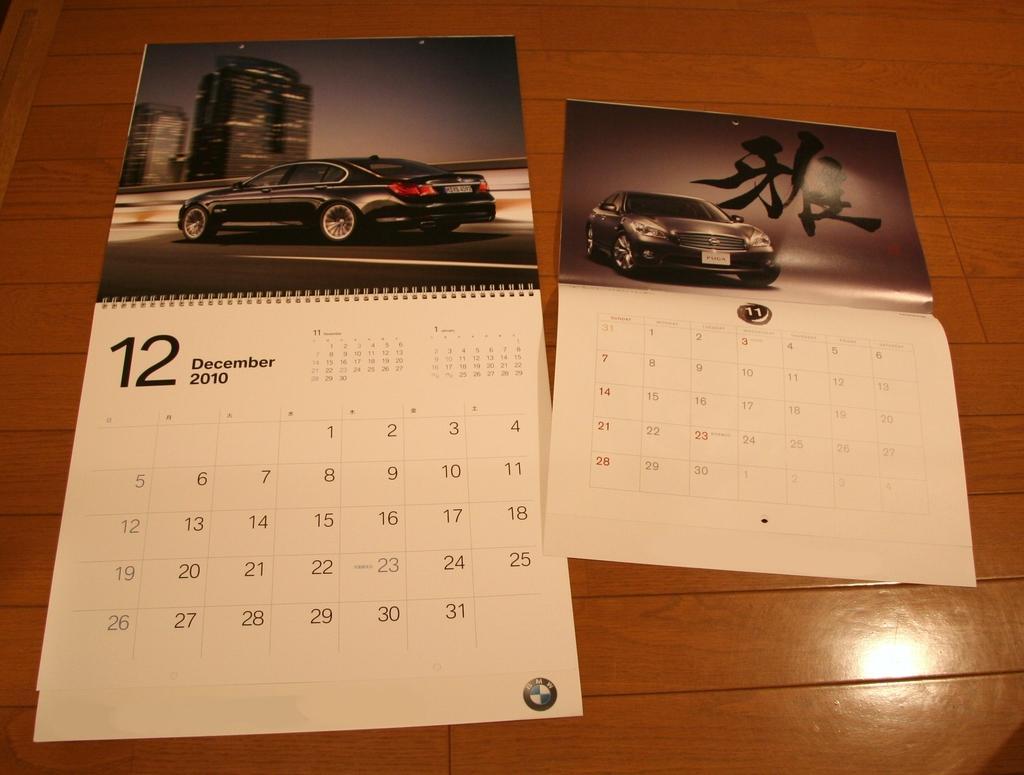How would you summarize this image in a sentence or two? In this picture, we can see calendars on the wooden object. 